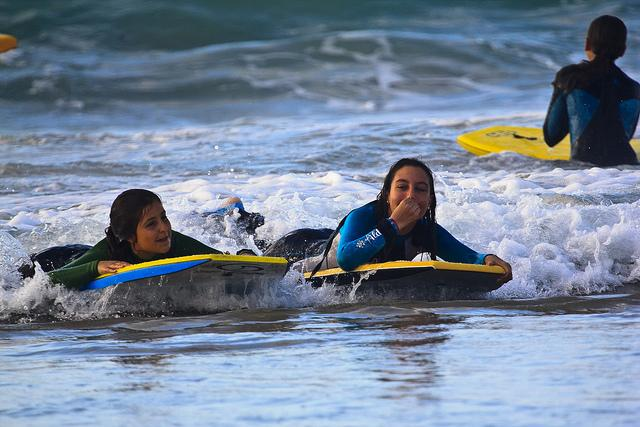Why are they lying down?

Choices:
A) to hide
B) to relax
C) to hunt
D) to sleep to relax 